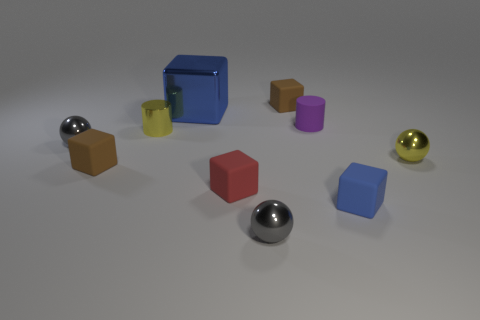Subtract 1 balls. How many balls are left? 2 Subtract all red rubber cubes. How many cubes are left? 4 Subtract all red blocks. How many blocks are left? 4 Subtract all cyan blocks. Subtract all purple spheres. How many blocks are left? 5 Subtract all cylinders. How many objects are left? 8 Subtract all tiny red things. Subtract all small gray spheres. How many objects are left? 7 Add 9 big cubes. How many big cubes are left? 10 Add 6 gray rubber spheres. How many gray rubber spheres exist? 6 Subtract 0 green cylinders. How many objects are left? 10 